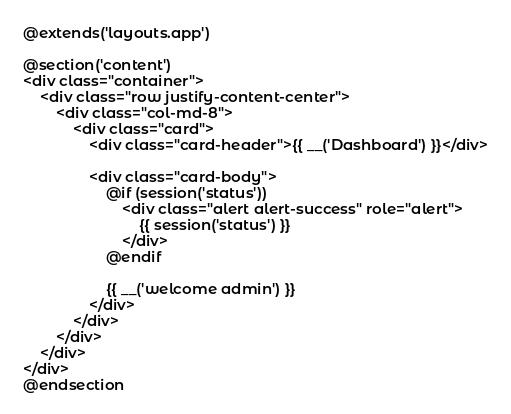Convert code to text. <code><loc_0><loc_0><loc_500><loc_500><_PHP_>@extends('layouts.app')

@section('content')
<div class="container">
    <div class="row justify-content-center">
        <div class="col-md-8">
            <div class="card">
                <div class="card-header">{{ __('Dashboard') }}</div>

                <div class="card-body">
                    @if (session('status'))
                        <div class="alert alert-success" role="alert">
                            {{ session('status') }}
                        </div>
                    @endif

                    {{ __('welcome admin') }}
                </div>
            </div>
        </div>
    </div>
</div>
@endsection
</code> 